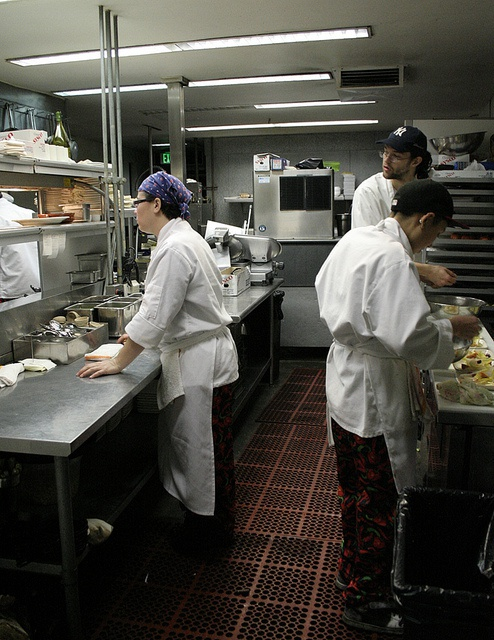Describe the objects in this image and their specific colors. I can see people in white, black, darkgray, lightgray, and gray tones, people in white, black, gray, darkgray, and lightgray tones, microwave in white, black, darkgray, and gray tones, people in white, black, lightgray, and darkgray tones, and people in white, lightgray, darkgray, gray, and black tones in this image. 